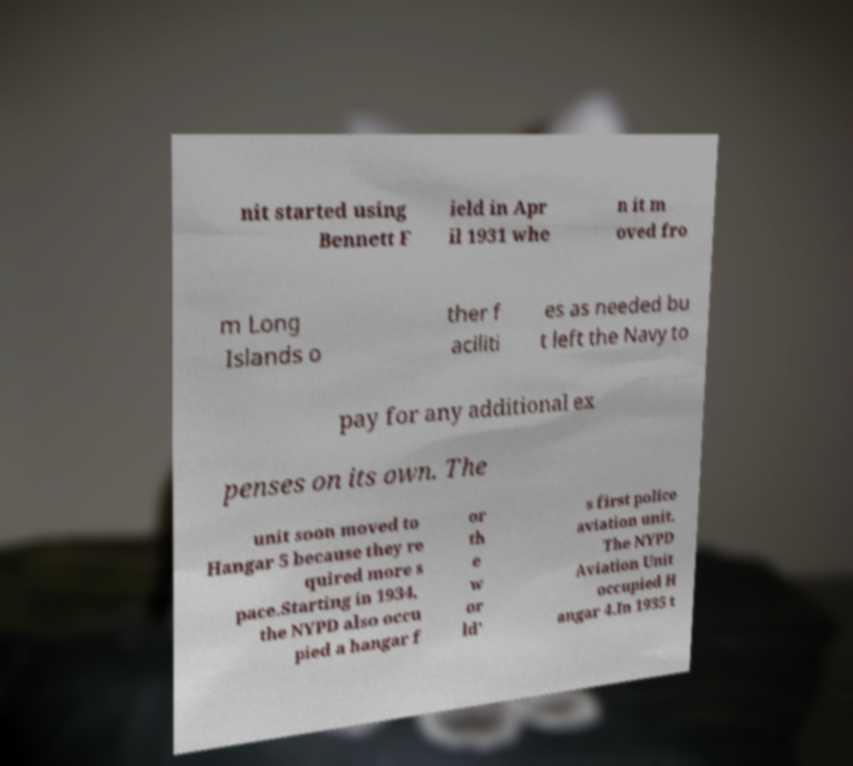Can you read and provide the text displayed in the image?This photo seems to have some interesting text. Can you extract and type it out for me? nit started using Bennett F ield in Apr il 1931 whe n it m oved fro m Long Islands o ther f aciliti es as needed bu t left the Navy to pay for any additional ex penses on its own. The unit soon moved to Hangar 5 because they re quired more s pace.Starting in 1934, the NYPD also occu pied a hangar f or th e w or ld' s first police aviation unit. The NYPD Aviation Unit occupied H angar 4.In 1935 t 